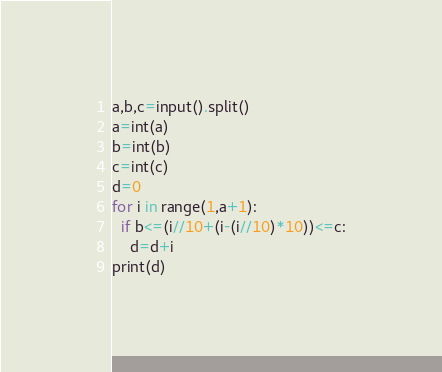Convert code to text. <code><loc_0><loc_0><loc_500><loc_500><_Python_>a,b,c=input().split()
a=int(a)
b=int(b)
c=int(c)
d=0
for i in range(1,a+1):
  if b<=(i//10+(i-(i//10)*10))<=c:
    d=d+i
print(d)</code> 